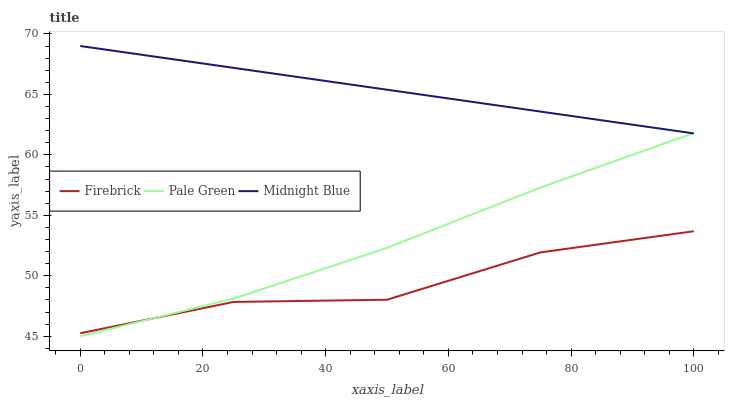Does Firebrick have the minimum area under the curve?
Answer yes or no. Yes. Does Midnight Blue have the maximum area under the curve?
Answer yes or no. Yes. Does Pale Green have the minimum area under the curve?
Answer yes or no. No. Does Pale Green have the maximum area under the curve?
Answer yes or no. No. Is Midnight Blue the smoothest?
Answer yes or no. Yes. Is Firebrick the roughest?
Answer yes or no. Yes. Is Pale Green the smoothest?
Answer yes or no. No. Is Pale Green the roughest?
Answer yes or no. No. Does Pale Green have the lowest value?
Answer yes or no. Yes. Does Midnight Blue have the lowest value?
Answer yes or no. No. Does Midnight Blue have the highest value?
Answer yes or no. Yes. Does Pale Green have the highest value?
Answer yes or no. No. Is Firebrick less than Midnight Blue?
Answer yes or no. Yes. Is Midnight Blue greater than Firebrick?
Answer yes or no. Yes. Does Midnight Blue intersect Pale Green?
Answer yes or no. Yes. Is Midnight Blue less than Pale Green?
Answer yes or no. No. Is Midnight Blue greater than Pale Green?
Answer yes or no. No. Does Firebrick intersect Midnight Blue?
Answer yes or no. No. 